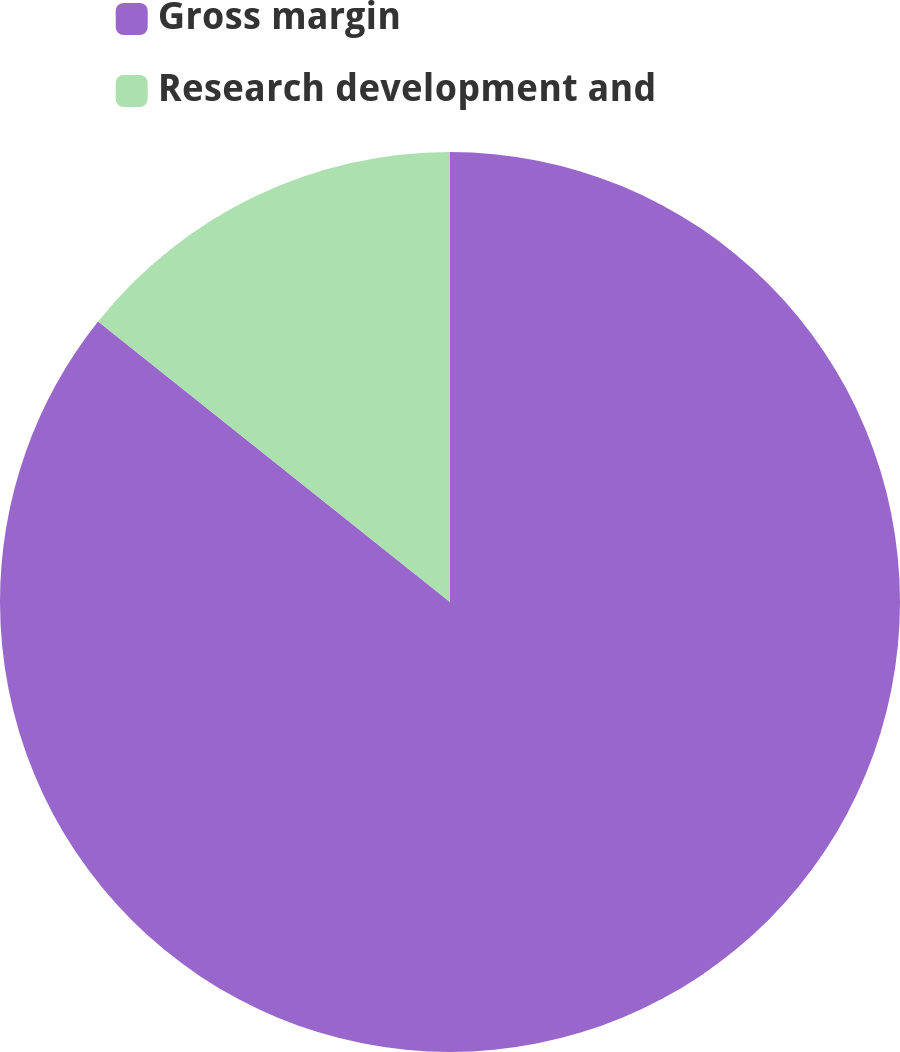<chart> <loc_0><loc_0><loc_500><loc_500><pie_chart><fcel>Gross margin<fcel>Research development and<nl><fcel>85.71%<fcel>14.29%<nl></chart> 